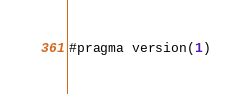Convert code to text. <code><loc_0><loc_0><loc_500><loc_500><_Rust_>#pragma version(1)</code> 